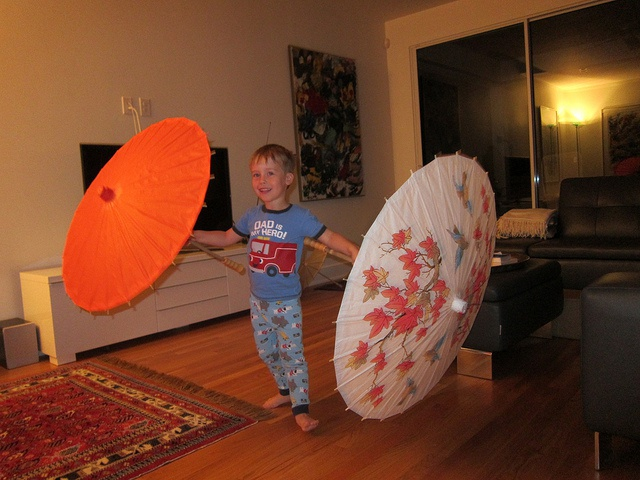Describe the objects in this image and their specific colors. I can see umbrella in tan, brown, and darkgray tones, umbrella in tan, red, brown, and maroon tones, people in tan, gray, maroon, and brown tones, couch in black, maroon, and tan tones, and couch in black, maroon, and tan tones in this image. 